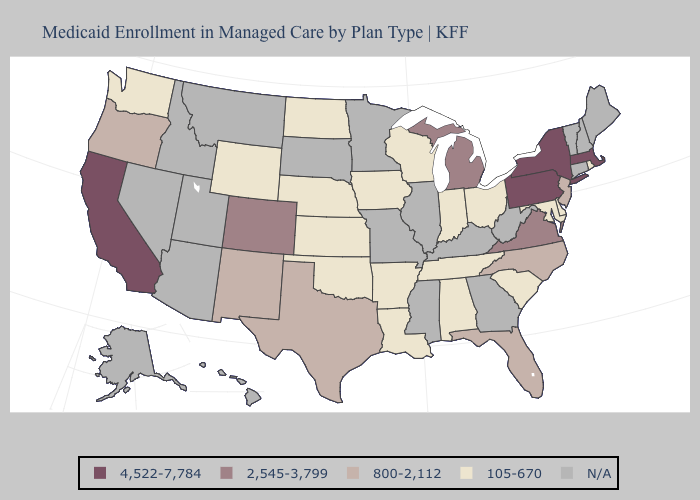What is the highest value in the Northeast ?
Be succinct. 4,522-7,784. Name the states that have a value in the range 800-2,112?
Give a very brief answer. Florida, New Jersey, New Mexico, North Carolina, Oregon, Texas. Name the states that have a value in the range 2,545-3,799?
Short answer required. Colorado, Michigan, Virginia. Name the states that have a value in the range 4,522-7,784?
Write a very short answer. California, Massachusetts, New York, Pennsylvania. What is the highest value in the MidWest ?
Give a very brief answer. 2,545-3,799. Does New York have the lowest value in the USA?
Short answer required. No. How many symbols are there in the legend?
Keep it brief. 5. Name the states that have a value in the range 2,545-3,799?
Be succinct. Colorado, Michigan, Virginia. Name the states that have a value in the range 2,545-3,799?
Concise answer only. Colorado, Michigan, Virginia. What is the value of South Dakota?
Be succinct. N/A. Which states hav the highest value in the South?
Short answer required. Virginia. What is the value of Rhode Island?
Concise answer only. 105-670. Which states hav the highest value in the Northeast?
Answer briefly. Massachusetts, New York, Pennsylvania. Among the states that border Maryland , which have the lowest value?
Keep it brief. Delaware. What is the value of Tennessee?
Answer briefly. 105-670. 